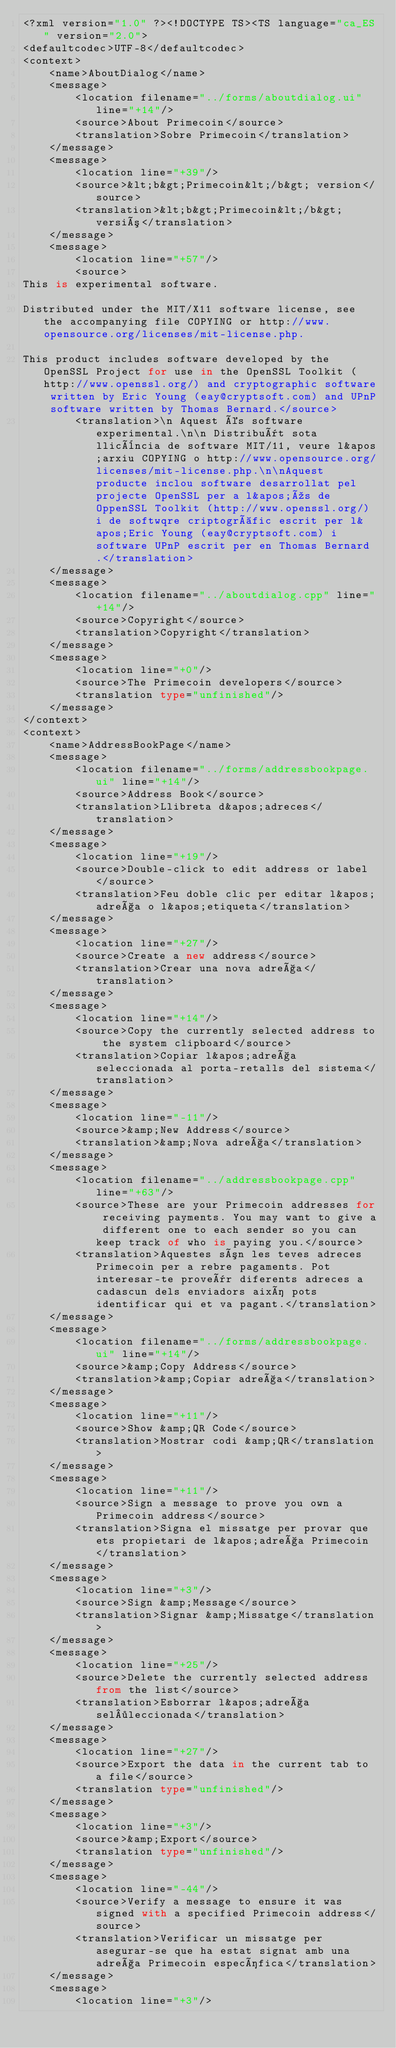Convert code to text. <code><loc_0><loc_0><loc_500><loc_500><_TypeScript_><?xml version="1.0" ?><!DOCTYPE TS><TS language="ca_ES" version="2.0">
<defaultcodec>UTF-8</defaultcodec>
<context>
    <name>AboutDialog</name>
    <message>
        <location filename="../forms/aboutdialog.ui" line="+14"/>
        <source>About Primecoin</source>
        <translation>Sobre Primecoin</translation>
    </message>
    <message>
        <location line="+39"/>
        <source>&lt;b&gt;Primecoin&lt;/b&gt; version</source>
        <translation>&lt;b&gt;Primecoin&lt;/b&gt; versió</translation>
    </message>
    <message>
        <location line="+57"/>
        <source>
This is experimental software.

Distributed under the MIT/X11 software license, see the accompanying file COPYING or http://www.opensource.org/licenses/mit-license.php.

This product includes software developed by the OpenSSL Project for use in the OpenSSL Toolkit (http://www.openssl.org/) and cryptographic software written by Eric Young (eay@cryptsoft.com) and UPnP software written by Thomas Bernard.</source>
        <translation>\n Aquest és software experimental.\n\n Distribuït sota llicència de software MIT/11, veure l&apos;arxiu COPYING o http://www.opensource.org/licenses/mit-license.php.\n\nAquest producte inclou software desarrollat pel projecte OpenSSL per a l&apos;ús de OppenSSL Toolkit (http://www.openssl.org/) i de softwqre criptogràfic escrit per l&apos;Eric Young (eay@cryptsoft.com) i software UPnP escrit per en Thomas Bernard.</translation>
    </message>
    <message>
        <location filename="../aboutdialog.cpp" line="+14"/>
        <source>Copyright</source>
        <translation>Copyright</translation>
    </message>
    <message>
        <location line="+0"/>
        <source>The Primecoin developers</source>
        <translation type="unfinished"/>
    </message>
</context>
<context>
    <name>AddressBookPage</name>
    <message>
        <location filename="../forms/addressbookpage.ui" line="+14"/>
        <source>Address Book</source>
        <translation>Llibreta d&apos;adreces</translation>
    </message>
    <message>
        <location line="+19"/>
        <source>Double-click to edit address or label</source>
        <translation>Feu doble clic per editar l&apos;adreça o l&apos;etiqueta</translation>
    </message>
    <message>
        <location line="+27"/>
        <source>Create a new address</source>
        <translation>Crear una nova adreça</translation>
    </message>
    <message>
        <location line="+14"/>
        <source>Copy the currently selected address to the system clipboard</source>
        <translation>Copiar l&apos;adreça seleccionada al porta-retalls del sistema</translation>
    </message>
    <message>
        <location line="-11"/>
        <source>&amp;New Address</source>
        <translation>&amp;Nova adreça</translation>
    </message>
    <message>
        <location filename="../addressbookpage.cpp" line="+63"/>
        <source>These are your Primecoin addresses for receiving payments. You may want to give a different one to each sender so you can keep track of who is paying you.</source>
        <translation>Aquestes són les teves adreces Primecoin per a rebre pagaments. Pot interesar-te proveïr diferents adreces a cadascun dels enviadors així pots identificar qui et va pagant.</translation>
    </message>
    <message>
        <location filename="../forms/addressbookpage.ui" line="+14"/>
        <source>&amp;Copy Address</source>
        <translation>&amp;Copiar adreça</translation>
    </message>
    <message>
        <location line="+11"/>
        <source>Show &amp;QR Code</source>
        <translation>Mostrar codi &amp;QR</translation>
    </message>
    <message>
        <location line="+11"/>
        <source>Sign a message to prove you own a Primecoin address</source>
        <translation>Signa el missatge per provar que ets propietari de l&apos;adreça Primecoin</translation>
    </message>
    <message>
        <location line="+3"/>
        <source>Sign &amp;Message</source>
        <translation>Signar &amp;Missatge</translation>
    </message>
    <message>
        <location line="+25"/>
        <source>Delete the currently selected address from the list</source>
        <translation>Esborrar l&apos;adreça sel·leccionada</translation>
    </message>
    <message>
        <location line="+27"/>
        <source>Export the data in the current tab to a file</source>
        <translation type="unfinished"/>
    </message>
    <message>
        <location line="+3"/>
        <source>&amp;Export</source>
        <translation type="unfinished"/>
    </message>
    <message>
        <location line="-44"/>
        <source>Verify a message to ensure it was signed with a specified Primecoin address</source>
        <translation>Verificar un missatge per asegurar-se que ha estat signat amb una adreça Primecoin específica</translation>
    </message>
    <message>
        <location line="+3"/></code> 